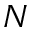Convert formula to latex. <formula><loc_0><loc_0><loc_500><loc_500>N</formula> 